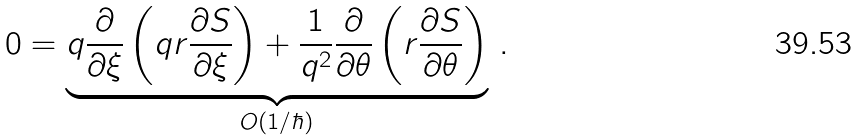<formula> <loc_0><loc_0><loc_500><loc_500>0 = \underbrace { q \frac { \partial } { \partial \xi } \left ( q r \frac { \partial S } { \partial \xi } \right ) + \frac { 1 } { q ^ { 2 } } \frac { \partial } { \partial \theta } \left ( r \frac { \partial S } { \partial \theta } \right ) } _ { O ( 1 / \hbar { ) } } \, .</formula> 